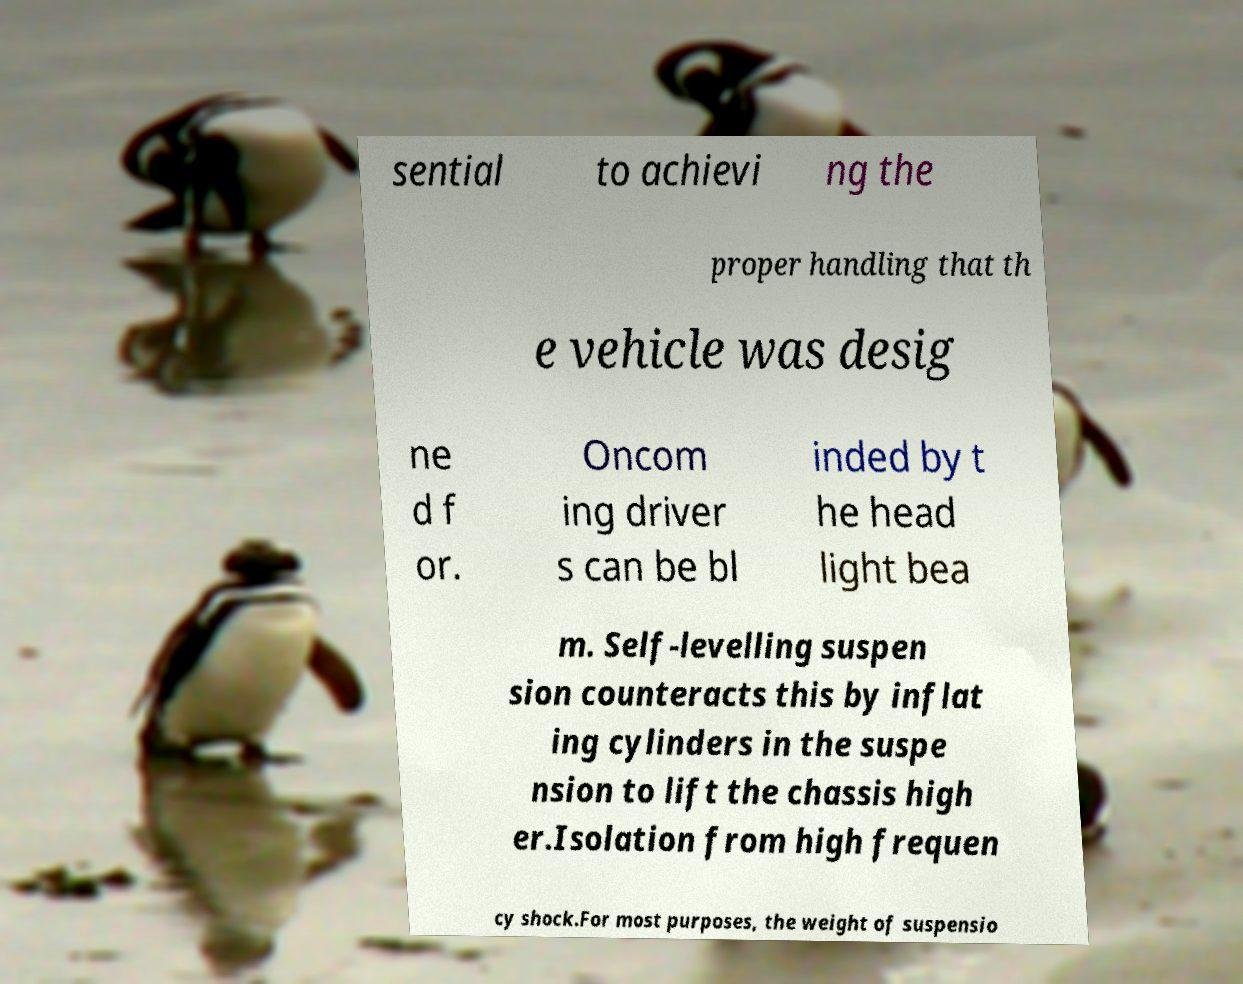Please identify and transcribe the text found in this image. sential to achievi ng the proper handling that th e vehicle was desig ne d f or. Oncom ing driver s can be bl inded by t he head light bea m. Self-levelling suspen sion counteracts this by inflat ing cylinders in the suspe nsion to lift the chassis high er.Isolation from high frequen cy shock.For most purposes, the weight of suspensio 